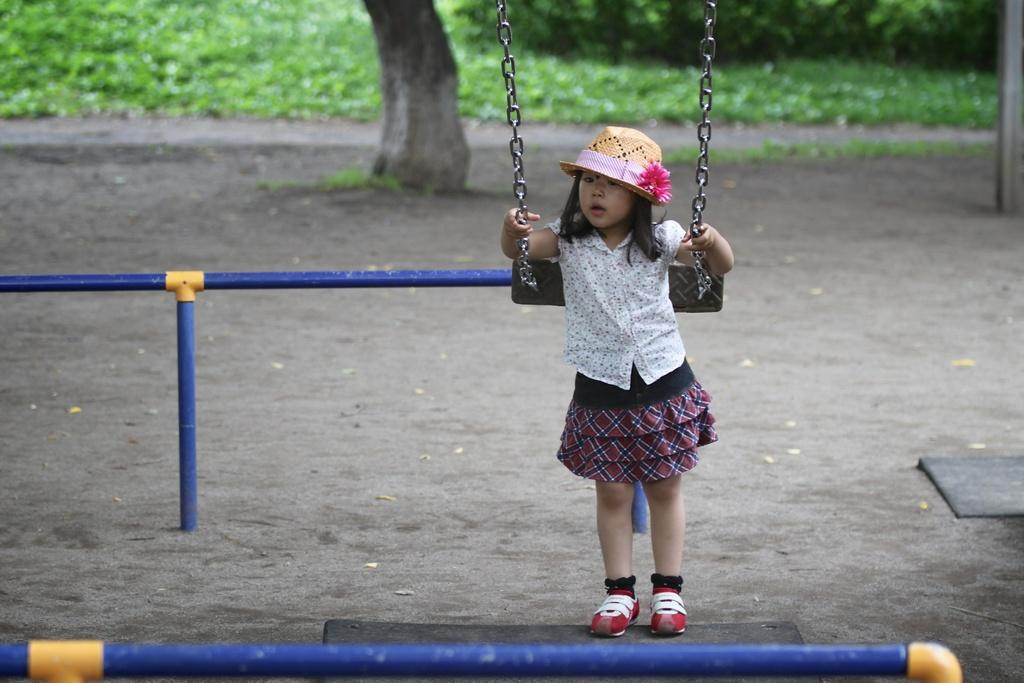Who is the main subject in the picture? There is a girl in the picture. What is the girl wearing on her head? The girl is wearing a cap. What is the girl holding in the picture? The girl is holding a cradle. What can be seen in the background of the picture? There are metal rods and trees in the background of the picture. What type of protest is the girl participating in, as seen in the image? There is no protest visible in the image; it features a girl holding a cradle. Who is the owner of the potato seen in the image? There is no potato present in the image. 